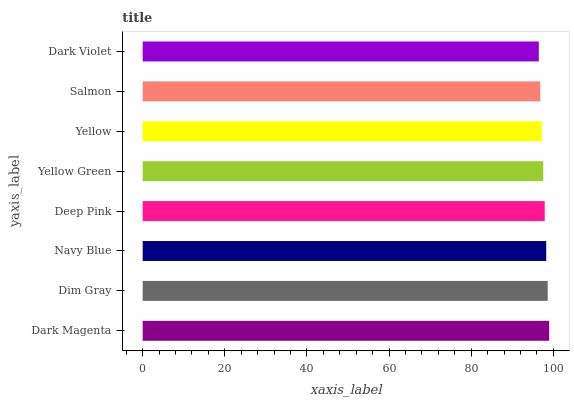Is Dark Violet the minimum?
Answer yes or no. Yes. Is Dark Magenta the maximum?
Answer yes or no. Yes. Is Dim Gray the minimum?
Answer yes or no. No. Is Dim Gray the maximum?
Answer yes or no. No. Is Dark Magenta greater than Dim Gray?
Answer yes or no. Yes. Is Dim Gray less than Dark Magenta?
Answer yes or no. Yes. Is Dim Gray greater than Dark Magenta?
Answer yes or no. No. Is Dark Magenta less than Dim Gray?
Answer yes or no. No. Is Deep Pink the high median?
Answer yes or no. Yes. Is Yellow Green the low median?
Answer yes or no. Yes. Is Yellow Green the high median?
Answer yes or no. No. Is Deep Pink the low median?
Answer yes or no. No. 